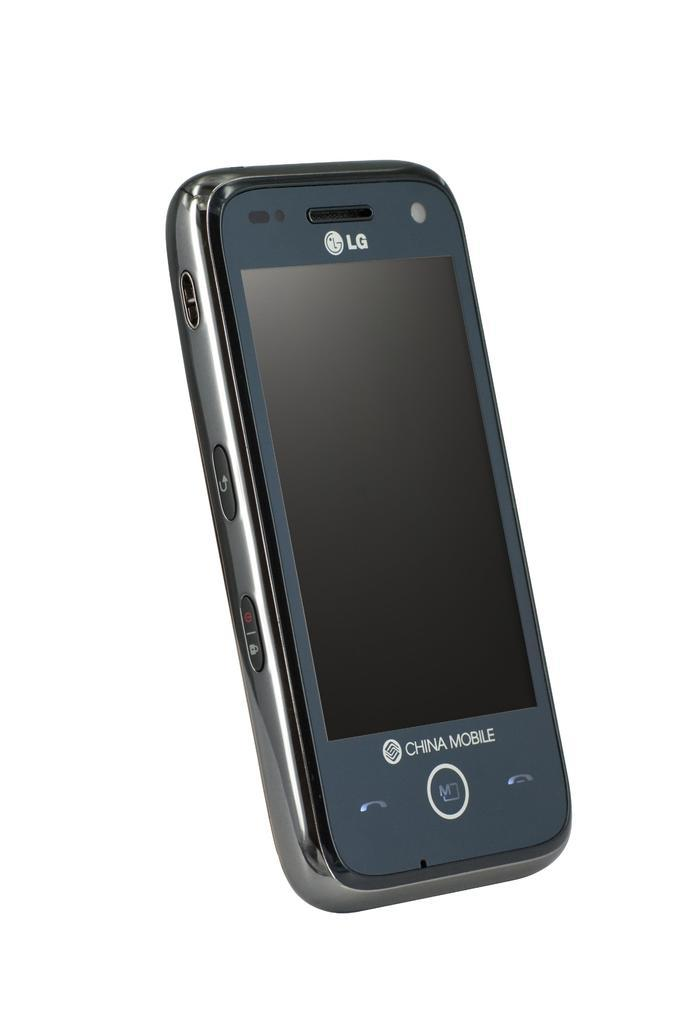Provide a one-sentence caption for the provided image. A Chinese Mobile LG phone in front of a white background. 